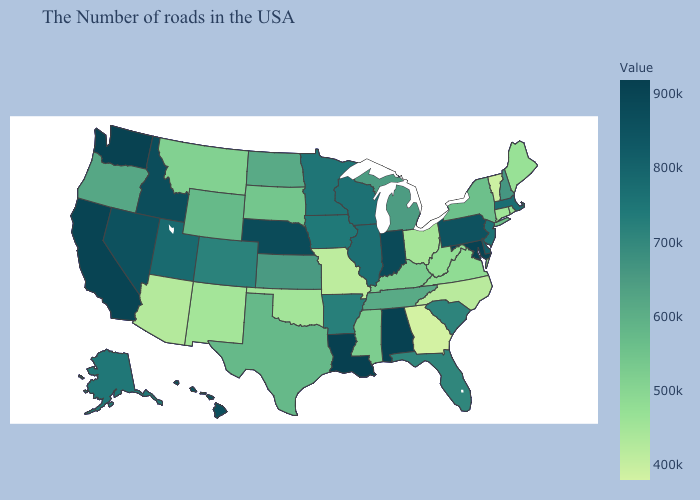Which states have the lowest value in the South?
Answer briefly. Georgia. Which states have the lowest value in the USA?
Short answer required. Georgia. Which states have the lowest value in the South?
Write a very short answer. Georgia. Which states have the highest value in the USA?
Concise answer only. Louisiana. Does Minnesota have the highest value in the MidWest?
Write a very short answer. No. Is the legend a continuous bar?
Write a very short answer. Yes. 